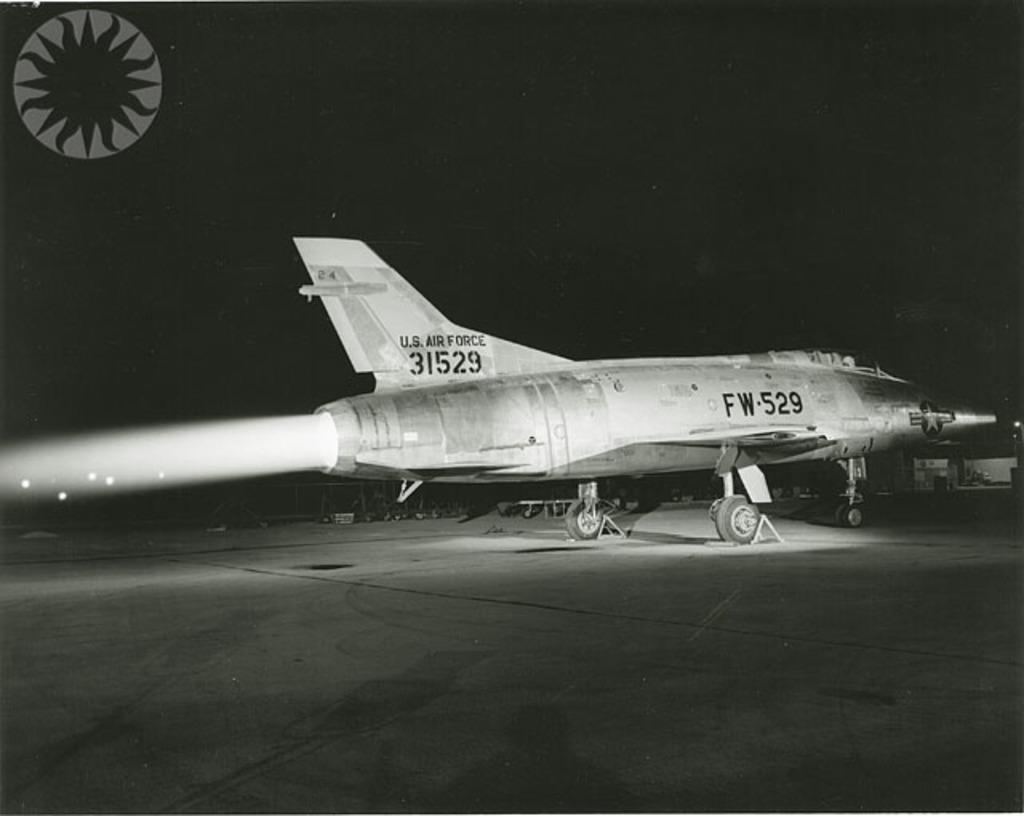What is the main subject of the image? The main subject of the image is an airplane on the ground. Can you describe any specific features of the airplane? Yes, there is a logo visible on the airplane. What else can be seen in the image besides the airplane? There are objects present in the image. What is the color of the background in the image? The background of the image is dark. What type of substance is being divided by the minister in the image? There is no minister or substance present in the image; it features an airplane on the ground with a logo and other objects. 